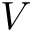<formula> <loc_0><loc_0><loc_500><loc_500>V</formula> 